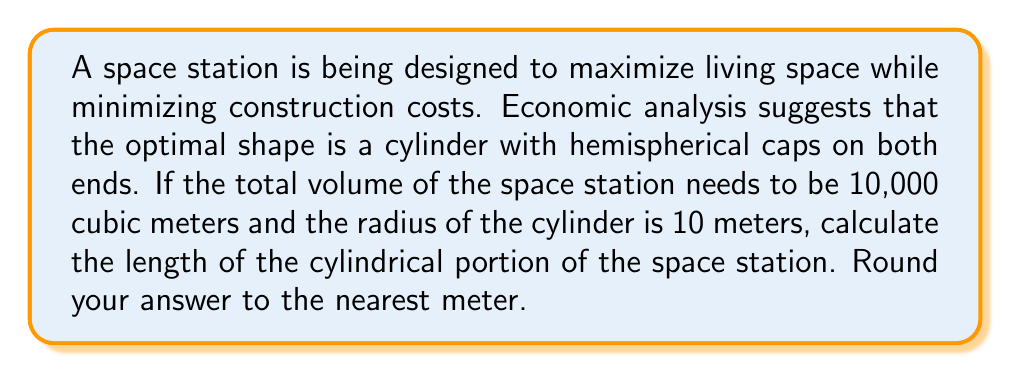Solve this math problem. To solve this problem, we need to follow these steps:

1) First, let's define our variables:
   $r$ = radius of cylinder and hemispheres = 10 meters
   $h$ = length of cylindrical portion (what we're solving for)
   $V$ = total volume = 10,000 cubic meters

2) The total volume consists of the volume of the cylinder and the volumes of the two hemispherical caps:

   $$V = V_{cylinder} + V_{hemisphere1} + V_{hemisphere2}$$

3) We know the formulas for these volumes:
   - Volume of a cylinder: $V_{cylinder} = \pi r^2 h$
   - Volume of a sphere: $V_{sphere} = \frac{4}{3}\pi r^3$
   - Volume of a hemisphere: $V_{hemisphere} = \frac{1}{2} \cdot \frac{4}{3}\pi r^3 = \frac{2}{3}\pi r^3$

4) Substituting these into our equation:

   $$10000 = \pi r^2 h + \frac{2}{3}\pi r^3 + \frac{2}{3}\pi r^3$$

5) Simplify:

   $$10000 = \pi r^2 h + \frac{4}{3}\pi r^3$$

6) Substitute $r = 10$:

   $$10000 = 100\pi h + \frac{4000\pi}{3}$$

7) Solve for $h$:

   $$10000 - \frac{4000\pi}{3} = 100\pi h$$
   
   $$h = \frac{10000 - \frac{4000\pi}{3}}{100\pi}$$

8) Calculate:

   $$h \approx 23.87 \text{ meters}$$

9) Rounding to the nearest meter:

   $$h \approx 24 \text{ meters}$$
Answer: The length of the cylindrical portion of the space station should be approximately 24 meters. 